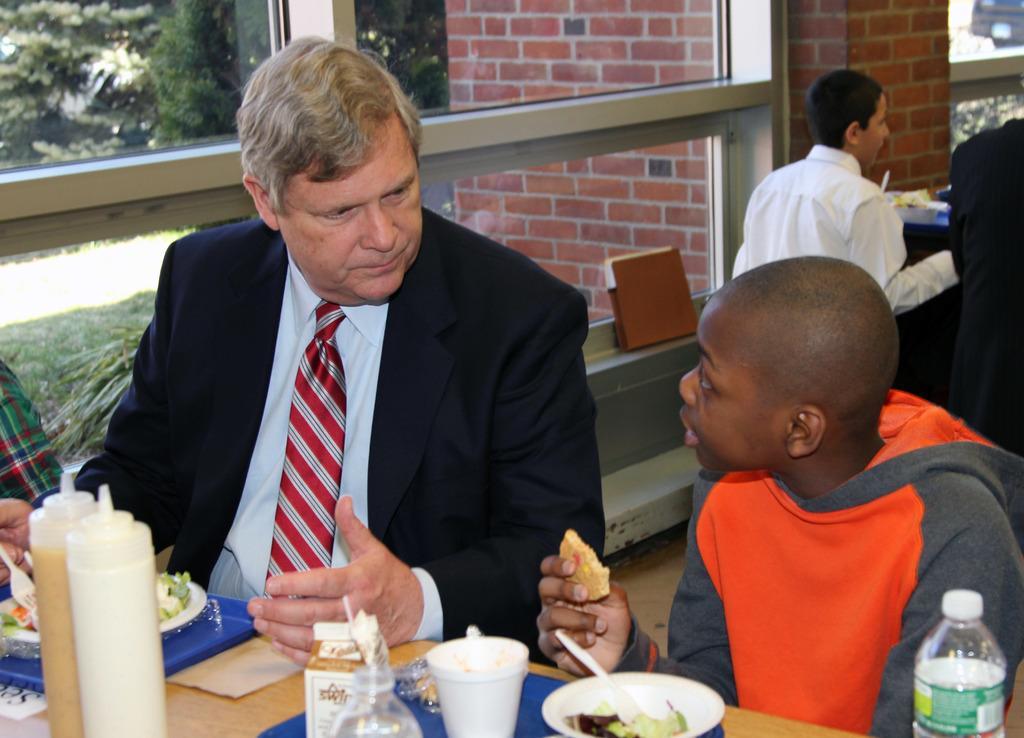Could you give a brief overview of what you see in this image? In this image I can see four persons sitting on the bench and in the foreground I can see two persons and in front of the persons I can see a table , on the table I can see food items and I can see red color bricks wall visible in the middle and trees visible at the top. 